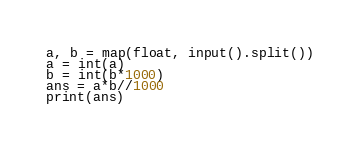<code> <loc_0><loc_0><loc_500><loc_500><_Python_>a, b = map(float, input().split())
a = int(a)
b = int(b*1000)
ans = a*b//1000
print(ans)
</code> 